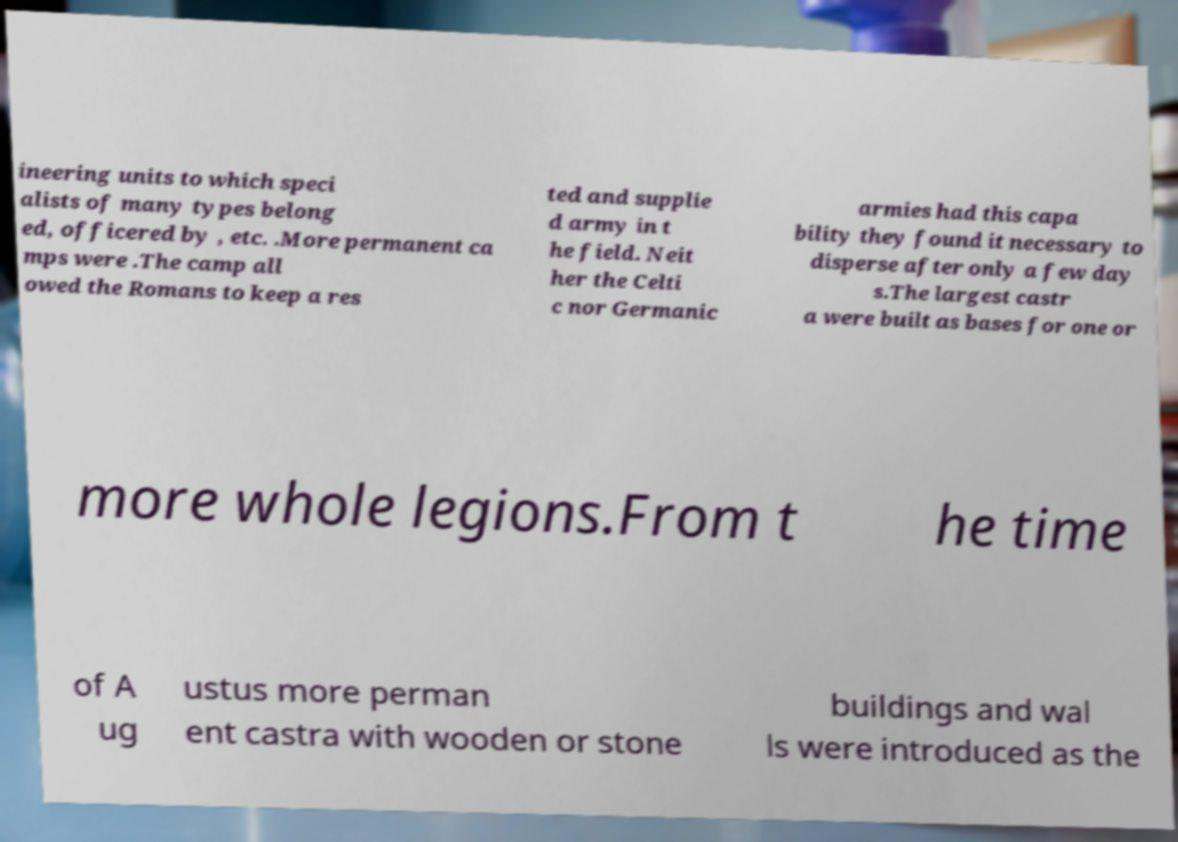Could you extract and type out the text from this image? ineering units to which speci alists of many types belong ed, officered by , etc. .More permanent ca mps were .The camp all owed the Romans to keep a res ted and supplie d army in t he field. Neit her the Celti c nor Germanic armies had this capa bility they found it necessary to disperse after only a few day s.The largest castr a were built as bases for one or more whole legions.From t he time of A ug ustus more perman ent castra with wooden or stone buildings and wal ls were introduced as the 